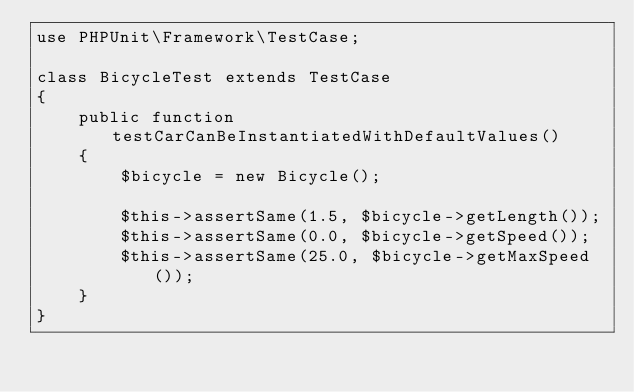<code> <loc_0><loc_0><loc_500><loc_500><_PHP_>use PHPUnit\Framework\TestCase;

class BicycleTest extends TestCase
{
    public function testCarCanBeInstantiatedWithDefaultValues()
    {
        $bicycle = new Bicycle();

        $this->assertSame(1.5, $bicycle->getLength());
        $this->assertSame(0.0, $bicycle->getSpeed());
        $this->assertSame(25.0, $bicycle->getMaxSpeed());
    }
}
</code> 